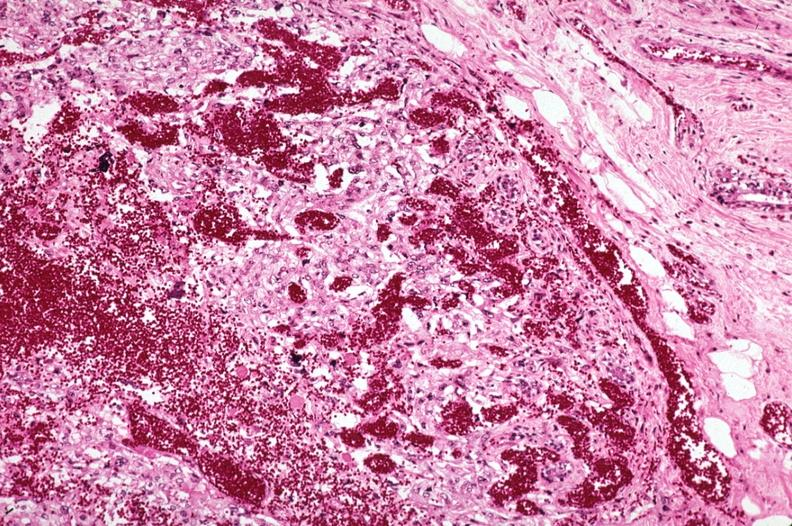how does this image show metastatic choriocarcinoma?
Answer the question using a single word or phrase. With extensive vascularization 